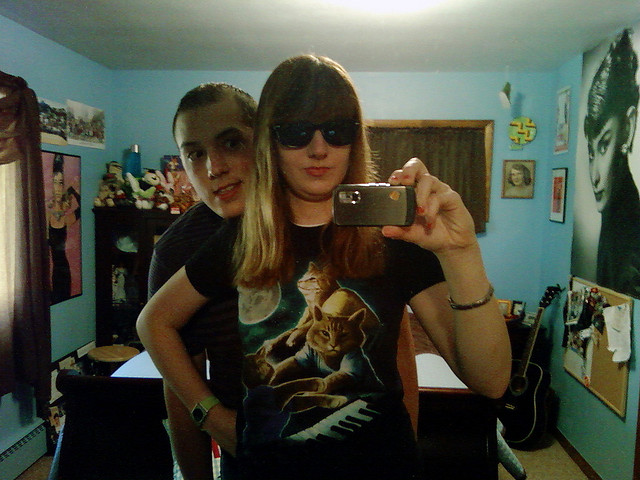<image>What rock band is on the black shirt? I am not sure. It could be any band, such as 'rockin' cats' or 'guns n roses'. It also could be 'piano cat' or 'kiss'. There might be no band on the black shirt. What rock band is on the black shirt? I don't know what rock band is on the black shirt. It can be 'cat rock band', "rockin' cats", 'guns n roses', 'cats', 'piano cat', or 'kiss'. 